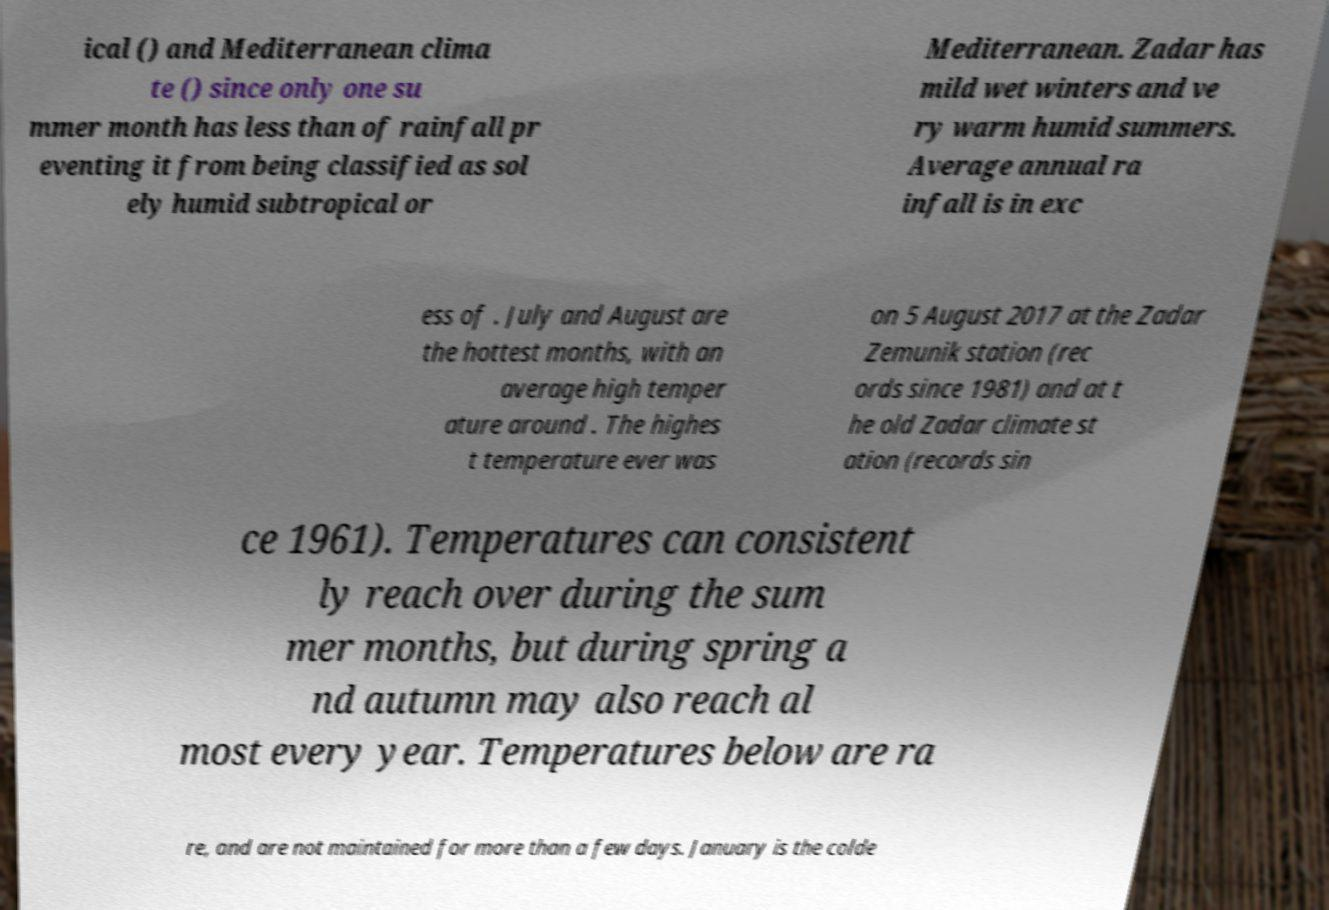Please identify and transcribe the text found in this image. ical () and Mediterranean clima te () since only one su mmer month has less than of rainfall pr eventing it from being classified as sol ely humid subtropical or Mediterranean. Zadar has mild wet winters and ve ry warm humid summers. Average annual ra infall is in exc ess of . July and August are the hottest months, with an average high temper ature around . The highes t temperature ever was on 5 August 2017 at the Zadar Zemunik station (rec ords since 1981) and at t he old Zadar climate st ation (records sin ce 1961). Temperatures can consistent ly reach over during the sum mer months, but during spring a nd autumn may also reach al most every year. Temperatures below are ra re, and are not maintained for more than a few days. January is the colde 